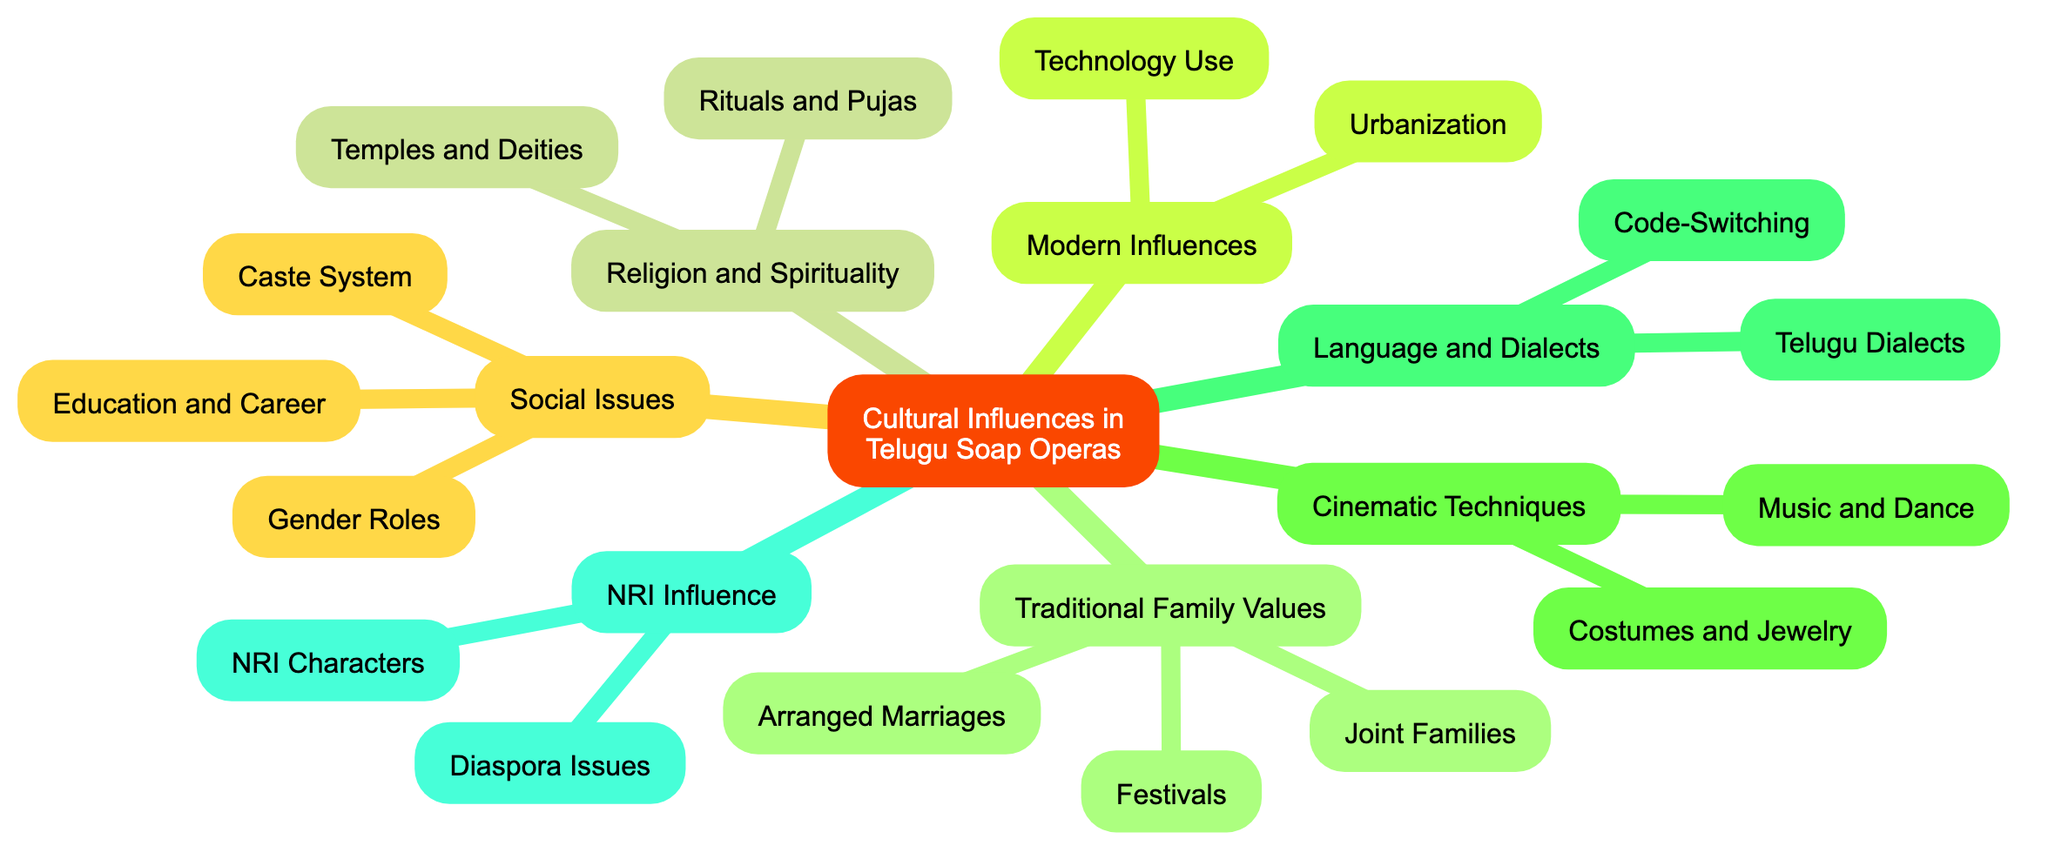What are the three subcategories under Traditional Family Values? The diagram shows a main node "Traditional Family Values," which branches out into three subcategories: Joint Families, Arranged Marriages, and Festivals.
Answer: Joint Families, Arranged Marriages, Festivals How is Urbanization depicted in the soap operas? The concept map illustrates Modern Influences, which includes Urbanization as a key aspect, indicating that soap operas contrast between rural and urban lifestyles.
Answer: Contrast between rural and urban lifestyles What role do Temples and Deities play in the narratives? Under the Religion and Spirituality section, the node Temples and Deities is linked to the portrayal of frequent visits to Hindu temples and references to deities, highlighting the spiritual influence in the storylines.
Answer: Frequent visits to Hindu temples and references to deities Which social issue is linked to Gender Roles? The diagram connects Gender Roles to the examination of traditional versus evolving roles of women in society, showcasing its relevance to social issues presented in the soap operas.
Answer: Examination of traditional vs. evolving roles of women in society How many influences are categorized under Modern Influences? The Modern Influences section contains two distinct influences—Urbanization and Technology Use—indicating that there are two categories in this part of the concept map.
Answer: 2 What is the significance of NRI Characters in Telugu soap operas? The NRI Influence section of the diagram specifies NRI Characters, detailing their inclusion in the narrative to reflect the lifestyles and traditions of people living abroad, thus addressing diaspora issues.
Answer: Inclusion of characters living abroad, their lifestyle and traditions 